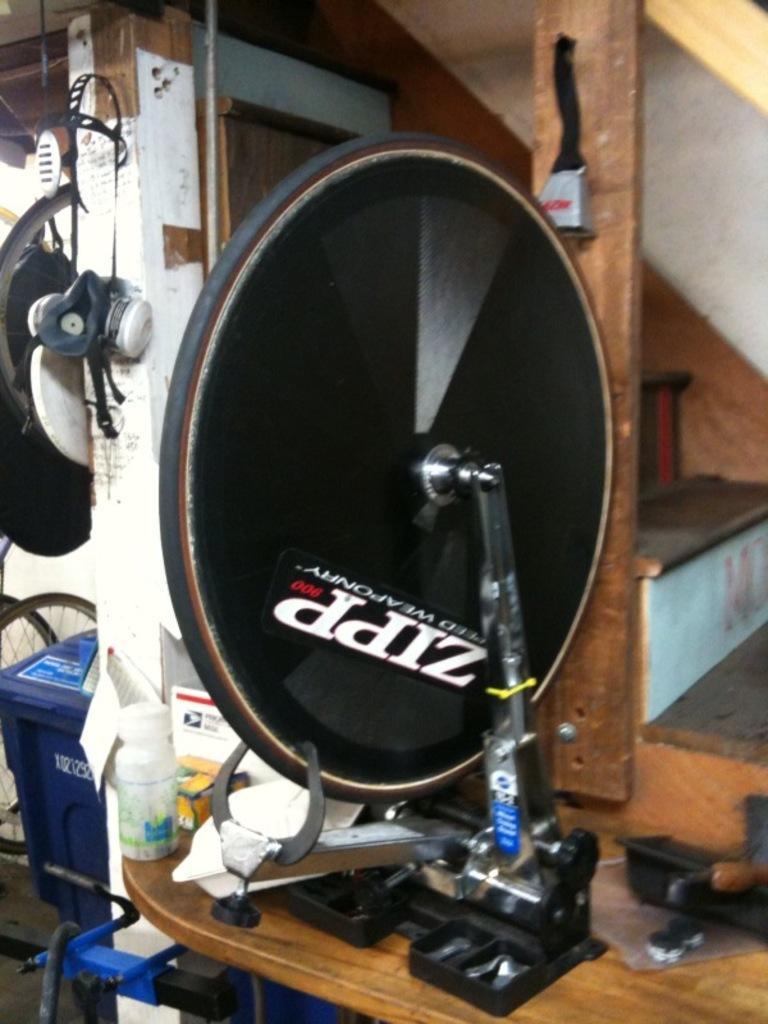In one or two sentences, can you explain what this image depicts? In the center of the image we can see a black color object and also a bottle on the wooden surface. In the background there is a trash bin. We can also see the stairs. 